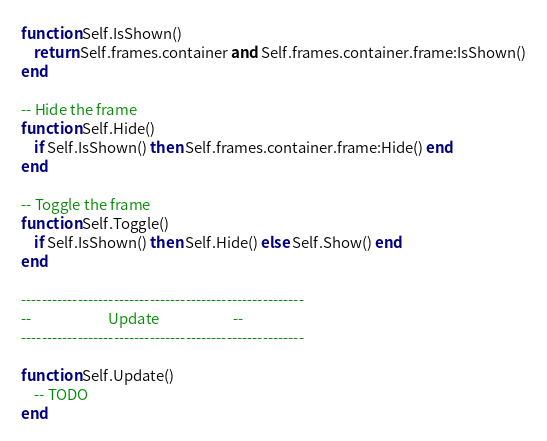Convert code to text. <code><loc_0><loc_0><loc_500><loc_500><_Lua_>function Self.IsShown()
    return Self.frames.container and Self.frames.container.frame:IsShown()
end

-- Hide the frame
function Self.Hide()
    if Self.IsShown() then Self.frames.container.frame:Hide() end
end

-- Toggle the frame
function Self.Toggle()
    if Self.IsShown() then Self.Hide() else Self.Show() end
end

-------------------------------------------------------
--                       Update                      --
-------------------------------------------------------

function Self.Update()
    -- TODO
end</code> 